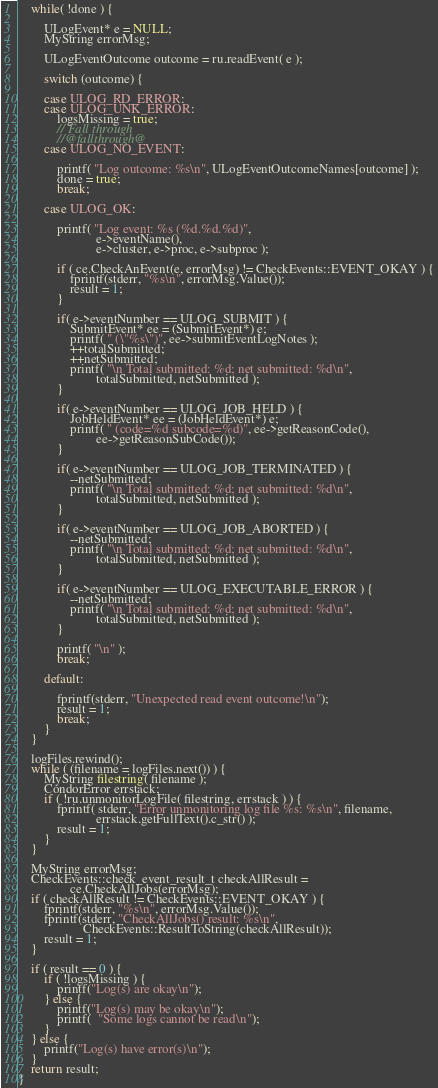Convert code to text. <code><loc_0><loc_0><loc_500><loc_500><_C++_>	while( !done ) {

    	ULogEvent* e = NULL;
		MyString errorMsg;

        ULogEventOutcome outcome = ru.readEvent( e );

        switch (outcome) {

        case ULOG_RD_ERROR:
        case ULOG_UNK_ERROR:
			logsMissing = true;
			// Fall through
			//@fallthrough@
        case ULOG_NO_EVENT:

			printf( "Log outcome: %s\n", ULogEventOutcomeNames[outcome] );
			done = true;
			break;
 
        case ULOG_OK:

			printf( "Log event: %s (%d.%d.%d)",
						e->eventName(),
						e->cluster, e->proc, e->subproc );

			if ( ce.CheckAnEvent(e, errorMsg) != CheckEvents::EVENT_OKAY ) {
				fprintf(stderr, "%s\n", errorMsg.Value());
				result = 1;
			}

			if( e->eventNumber == ULOG_SUBMIT ) {
				SubmitEvent* ee = (SubmitEvent*) e;
				printf( " (\"%s\")", ee->submitEventLogNotes );
				++totalSubmitted;
				++netSubmitted;
				printf( "\n Total submitted: %d; net submitted: %d\n",
						totalSubmitted, netSubmitted );
			}
			
			if( e->eventNumber == ULOG_JOB_HELD ) {
				JobHeldEvent* ee = (JobHeldEvent*) e;
				printf( " (code=%d subcode=%d)", ee->getReasonCode(),
						ee->getReasonSubCode());
			}

			if( e->eventNumber == ULOG_JOB_TERMINATED ) {
				--netSubmitted;
				printf( "\n Total submitted: %d; net submitted: %d\n",
						totalSubmitted, netSubmitted );
			}

			if( e->eventNumber == ULOG_JOB_ABORTED ) {
				--netSubmitted;
				printf( "\n Total submitted: %d; net submitted: %d\n",
						totalSubmitted, netSubmitted );
			}

			if( e->eventNumber == ULOG_EXECUTABLE_ERROR ) {
				--netSubmitted;
				printf( "\n Total submitted: %d; net submitted: %d\n",
						totalSubmitted, netSubmitted );
			}

			printf( "\n" );
			break;

		default:

			fprintf(stderr, "Unexpected read event outcome!\n");
			result = 1;
			break;
        }
	}

	logFiles.rewind();
	while ( (filename = logFiles.next()) ) {
		MyString filestring( filename );
		CondorError errstack;
		if ( !ru.unmonitorLogFile( filestring, errstack ) ) {
			fprintf( stderr, "Error unmonitoring log file %s: %s\n", filename,
						errstack.getFullText().c_str() );
			result = 1;
		}
	}

	MyString errorMsg;
	CheckEvents::check_event_result_t checkAllResult =
				ce.CheckAllJobs(errorMsg);
	if ( checkAllResult != CheckEvents::EVENT_OKAY ) {
		fprintf(stderr, "%s\n", errorMsg.Value());
		fprintf(stderr, "CheckAllJobs() result: %s\n",
					CheckEvents::ResultToString(checkAllResult));
		result = 1;
	}

	if ( result == 0 ) {
		if ( !logsMissing ) {
			printf("Log(s) are okay\n");
		} else {
			printf("Log(s) may be okay\n");
			printf(  "Some logs cannot be read\n");
		}
	} else {
		printf("Log(s) have error(s)\n");
	}
	return result;
}
</code> 